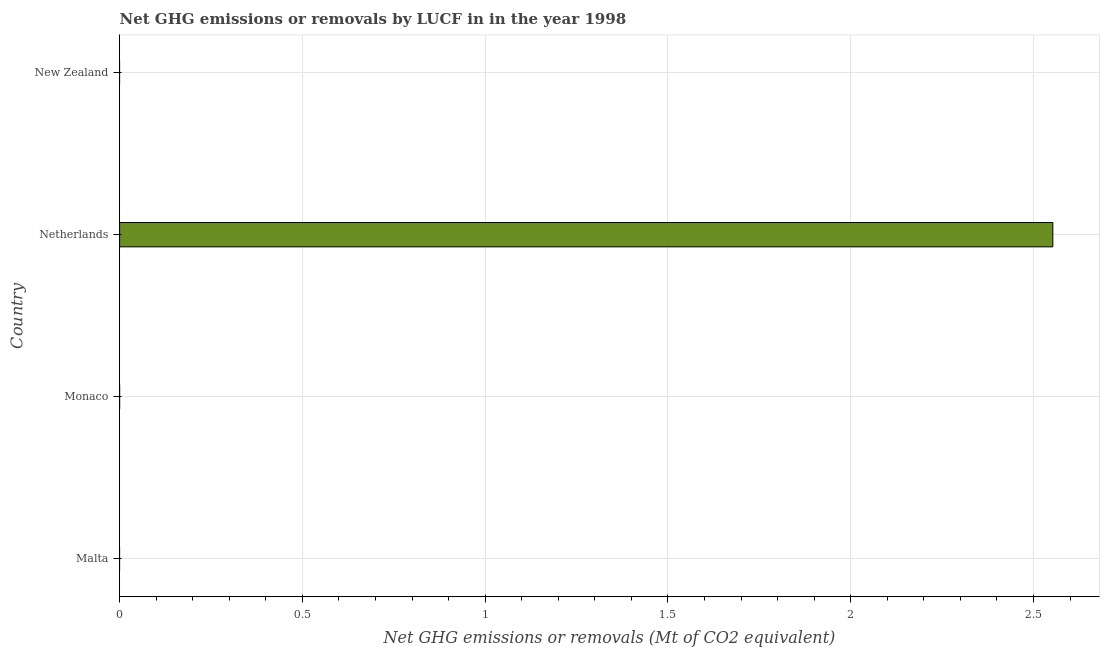Does the graph contain grids?
Your answer should be very brief. Yes. What is the title of the graph?
Provide a succinct answer. Net GHG emissions or removals by LUCF in in the year 1998. What is the label or title of the X-axis?
Give a very brief answer. Net GHG emissions or removals (Mt of CO2 equivalent). What is the ghg net emissions or removals in Malta?
Give a very brief answer. 0. Across all countries, what is the maximum ghg net emissions or removals?
Your response must be concise. 2.55. Across all countries, what is the minimum ghg net emissions or removals?
Your response must be concise. 0. In which country was the ghg net emissions or removals maximum?
Your answer should be very brief. Netherlands. What is the sum of the ghg net emissions or removals?
Offer a terse response. 2.55. What is the average ghg net emissions or removals per country?
Ensure brevity in your answer.  0.64. What is the median ghg net emissions or removals?
Your response must be concise. 0. What is the difference between the highest and the lowest ghg net emissions or removals?
Your response must be concise. 2.55. In how many countries, is the ghg net emissions or removals greater than the average ghg net emissions or removals taken over all countries?
Your answer should be compact. 1. How many bars are there?
Provide a short and direct response. 1. How many countries are there in the graph?
Your response must be concise. 4. What is the Net GHG emissions or removals (Mt of CO2 equivalent) in Malta?
Your answer should be very brief. 0. What is the Net GHG emissions or removals (Mt of CO2 equivalent) in Netherlands?
Make the answer very short. 2.55. 